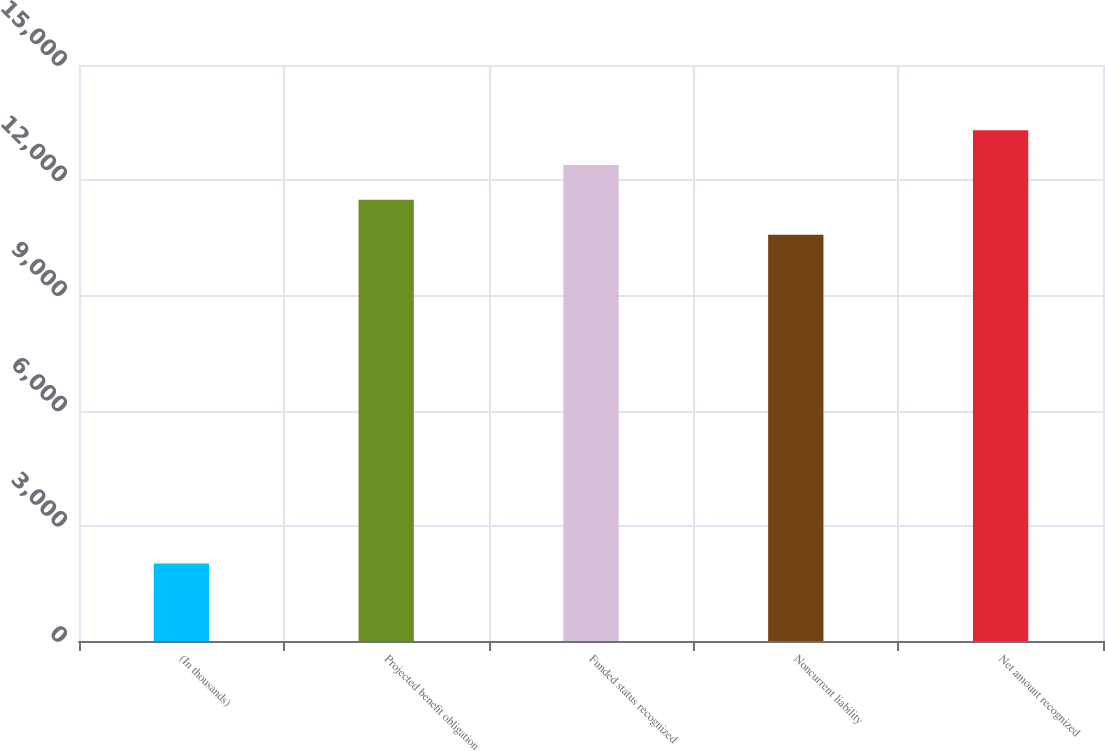Convert chart to OTSL. <chart><loc_0><loc_0><loc_500><loc_500><bar_chart><fcel>(In thousands)<fcel>Projected benefit obligation<fcel>Funded status recognized<fcel>Noncurrent liability<fcel>Net amount recognized<nl><fcel>2019<fcel>11488.3<fcel>12394.6<fcel>10582<fcel>13300.9<nl></chart> 